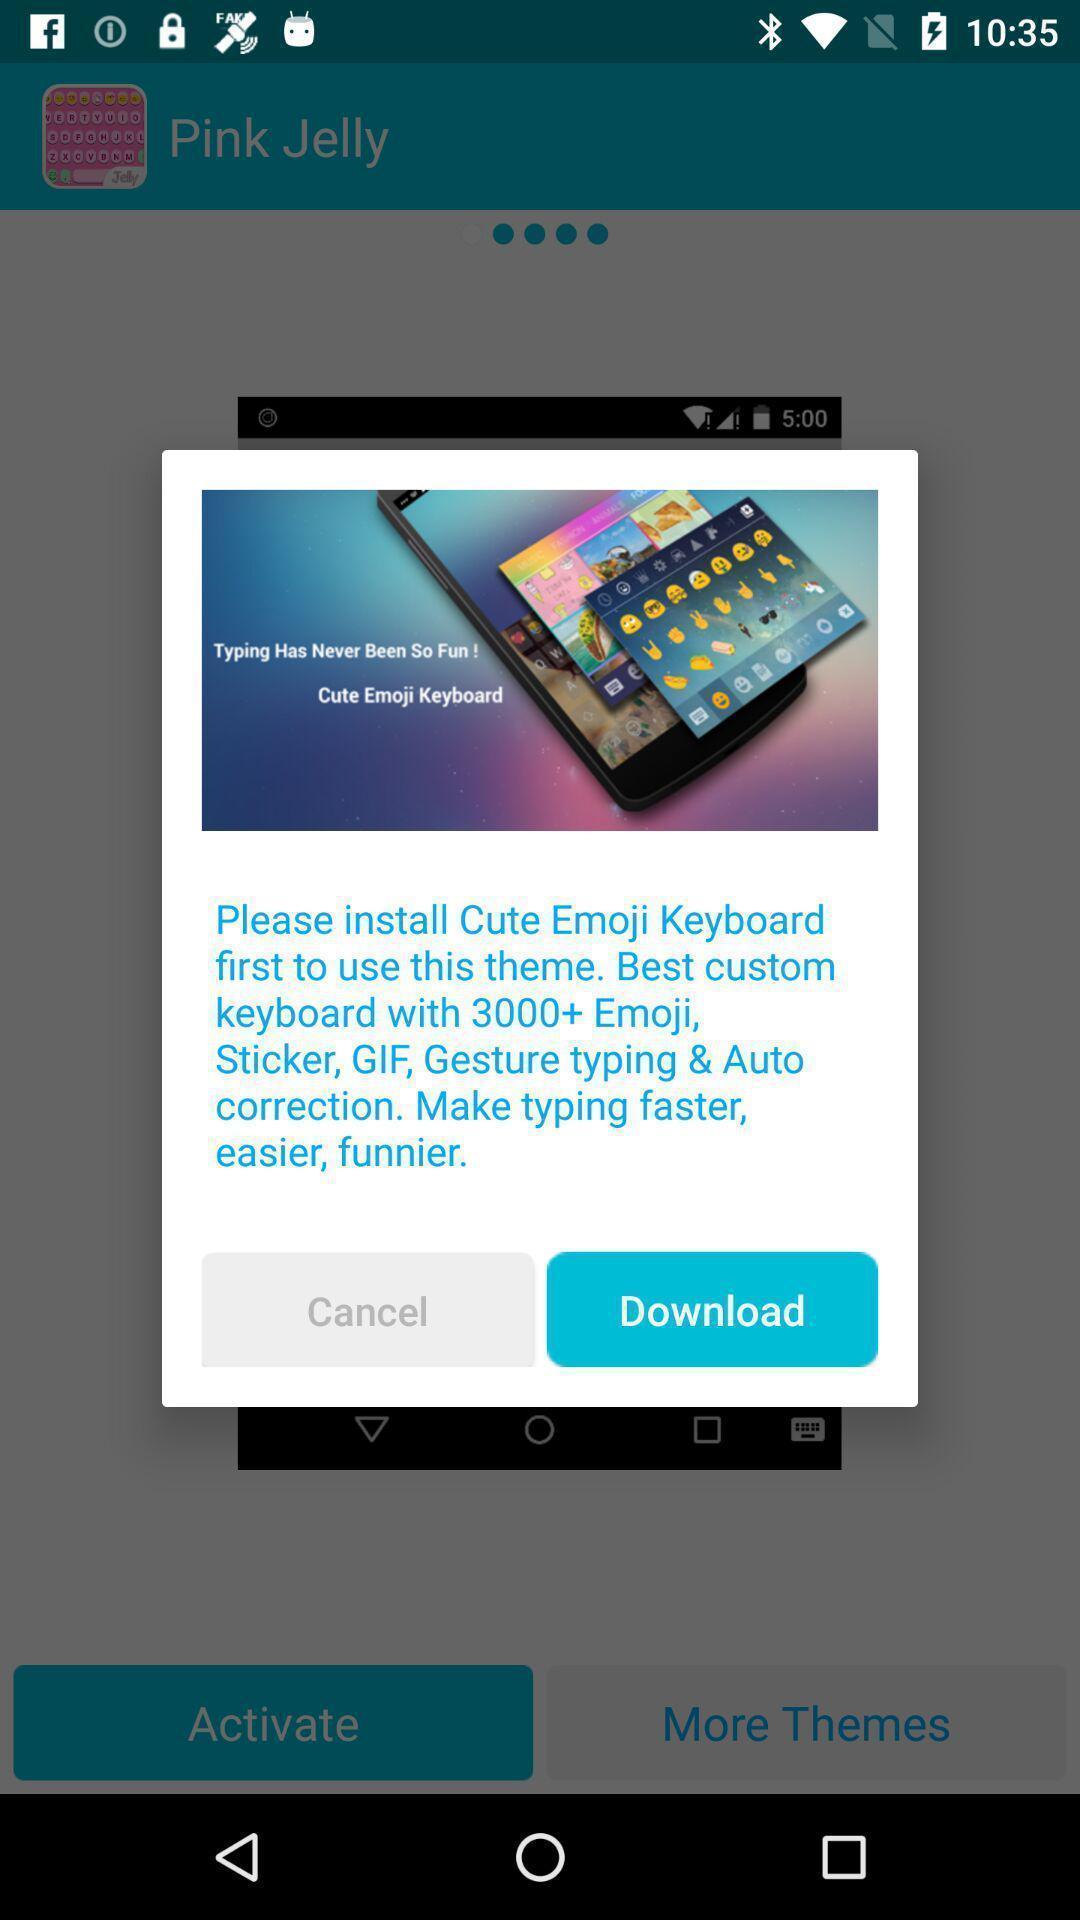Describe the visual elements of this screenshot. Popup displaying information about app. 